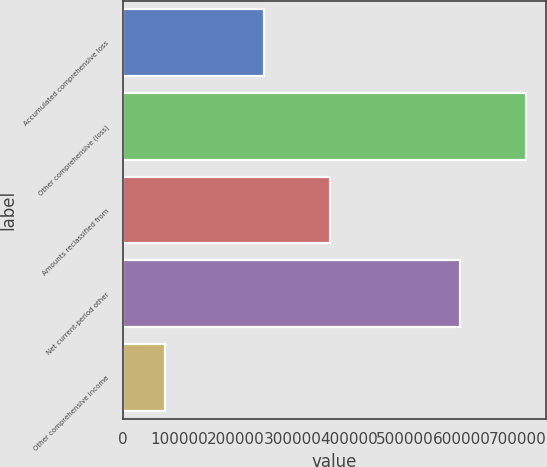Convert chart. <chart><loc_0><loc_0><loc_500><loc_500><bar_chart><fcel>Accumulated comprehensive loss<fcel>Other comprehensive (loss)<fcel>Amounts reclassified from<fcel>Net current-period other<fcel>Other comprehensive income<nl><fcel>250355<fcel>713595<fcel>366165<fcel>597785<fcel>73973<nl></chart> 